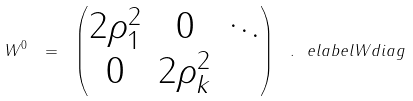Convert formula to latex. <formula><loc_0><loc_0><loc_500><loc_500>W ^ { 0 } \ = \ \begin{pmatrix} 2 \rho _ { 1 } ^ { 2 } & { 0 } & \ddots \\ { 0 } & 2 \rho _ { k } ^ { 2 } \end{pmatrix} \ . \ e l a b e l { W d i a g }</formula> 